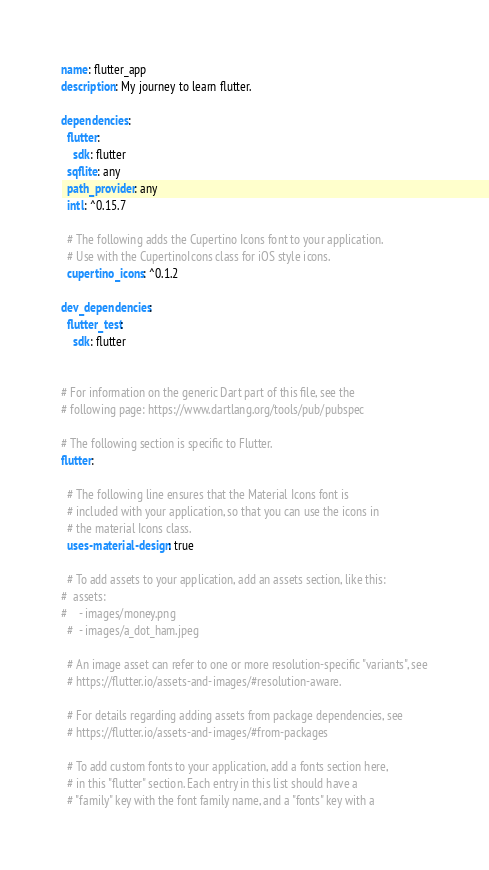<code> <loc_0><loc_0><loc_500><loc_500><_YAML_>name: flutter_app
description: My journey to learn flutter.

dependencies:
  flutter:
    sdk: flutter
  sqflite: any
  path_provider: any
  intl: ^0.15.7

  # The following adds the Cupertino Icons font to your application.
  # Use with the CupertinoIcons class for iOS style icons.
  cupertino_icons: ^0.1.2

dev_dependencies:
  flutter_test:
    sdk: flutter


# For information on the generic Dart part of this file, see the
# following page: https://www.dartlang.org/tools/pub/pubspec

# The following section is specific to Flutter.
flutter:

  # The following line ensures that the Material Icons font is
  # included with your application, so that you can use the icons in
  # the material Icons class.
  uses-material-design: true

  # To add assets to your application, add an assets section, like this:
#  assets:
#    - images/money.png
  #  - images/a_dot_ham.jpeg

  # An image asset can refer to one or more resolution-specific "variants", see
  # https://flutter.io/assets-and-images/#resolution-aware.

  # For details regarding adding assets from package dependencies, see
  # https://flutter.io/assets-and-images/#from-packages

  # To add custom fonts to your application, add a fonts section here,
  # in this "flutter" section. Each entry in this list should have a
  # "family" key with the font family name, and a "fonts" key with a</code> 